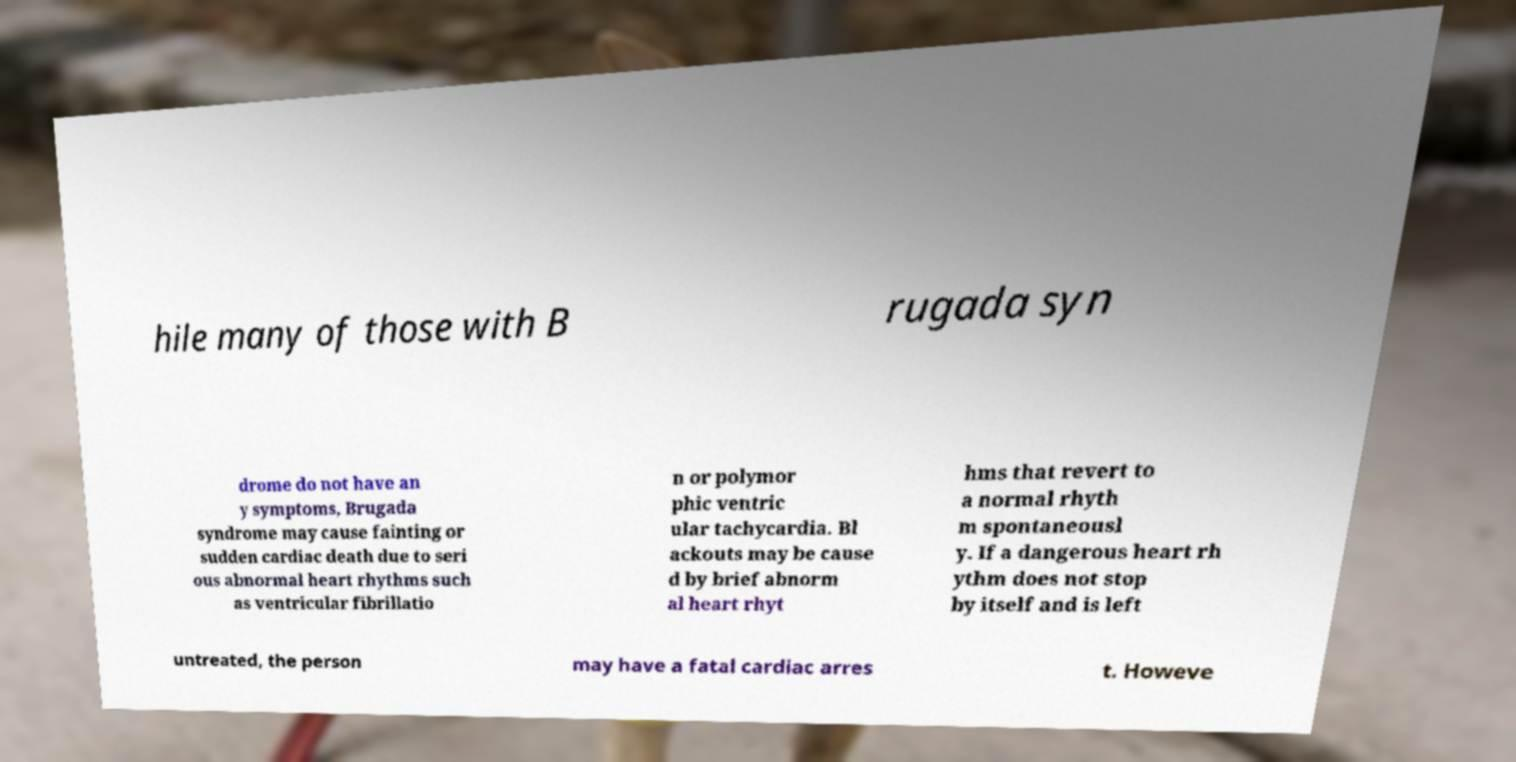Could you extract and type out the text from this image? hile many of those with B rugada syn drome do not have an y symptoms, Brugada syndrome may cause fainting or sudden cardiac death due to seri ous abnormal heart rhythms such as ventricular fibrillatio n or polymor phic ventric ular tachycardia. Bl ackouts may be cause d by brief abnorm al heart rhyt hms that revert to a normal rhyth m spontaneousl y. If a dangerous heart rh ythm does not stop by itself and is left untreated, the person may have a fatal cardiac arres t. Howeve 